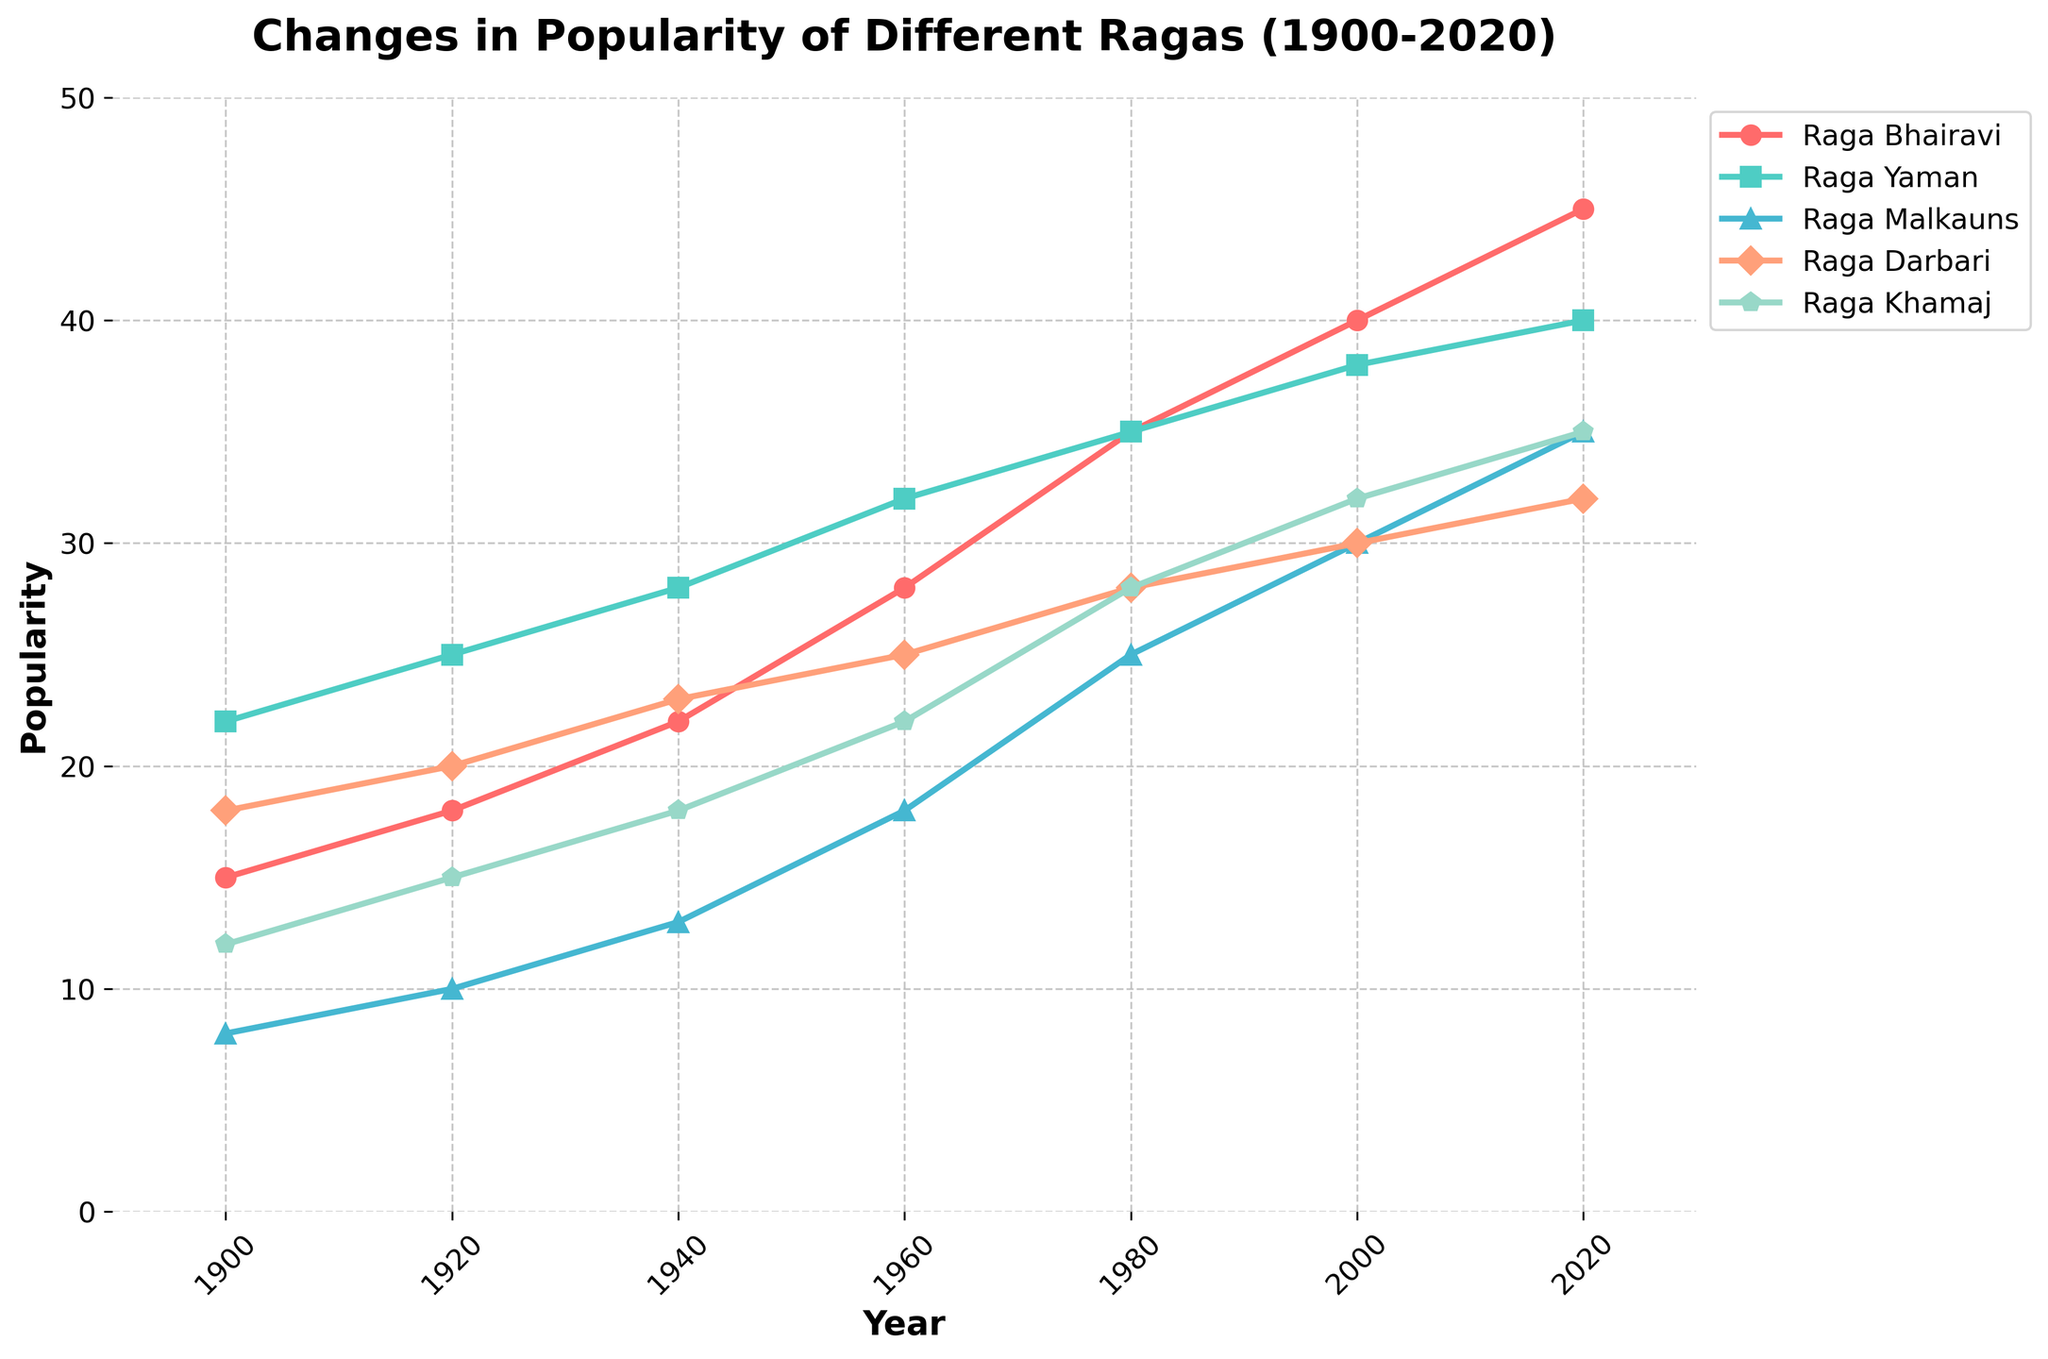Which raga was the most popular in 1900? Looking at the initial data points for each raga in 1900, Raga Yaman has the highest popularity value with a score of 22.
Answer: Raga Yaman Which raga shows the most significant increase in popularity from 1900 to 2020? Calculate the difference in popularity for each raga between 1900 and 2020. Raga Bhairavi: 45-15 = 30, Raga Yaman: 40-22 = 18, Raga Malkauns: 35-8 = 27, Raga Darbari: 32-18 = 14, Raga Khamaj: 35-12 = 23. The largest increase is seen in Raga Bhairavi.
Answer: Raga Bhairavi Which two raga's popularity values were equal in 2000? In the year 2000, look at the popularity values. Raga Malkauns = 30, Raga Darbari = 30. Thus, both ragas have equal popularity values in 2000.
Answer: Raga Malkauns and Raga Darbari What is the average popularity of Raga Khamaj between 1900 and 2020? Add up all the popularity values of Raga Khamaj and divide by the number of years. (12+15+18+22+28+32+35)/7 = 162/7 ≈ 23.14.
Answer: 23.14 Between 1960 and 1980, which raga shows the least change in popularity? Calculate the change in popularity for each raga between 1960 and 1980. Raga Bhairavi: 35-28 = 7, Raga Yaman: 35-32 = 3, Raga Malkauns: 25-18 = 7, Raga Darbari: 28-25 = 3, Raga Khamaj: 28-22 = 6. Both Raga Yaman and Raga Darbari have the least change, which is 3 units.
Answer: Raga Yaman and Raga Darbari How many ragas had a popularity value greater than 30 in 2000? Checking the values for the year 2000, Raga Yaman = 38, Raga Malkauns = 30, Raga Bhairavi = 40, Raga Darbari = 30, Raga Khamaj = 32. Thus, 3 ragas have a value greater than 30.
Answer: 3 Which raga reached a popularity value of 35 first? Analyze the data and note when each raga hits the value of 35. Raga Bhairavi hits 35 in 1980, and no other raga reaches 35 before this year.
Answer: Raga Bhairavi How does the popularity of Raga Malkauns in 1940 compare to that of Raga Yaman in 2020? Compare the values from the given years. Raga Malkauns in 1940 is 13, and Raga Yaman in 2020 is 40. 13 < 40.
Answer: Less 